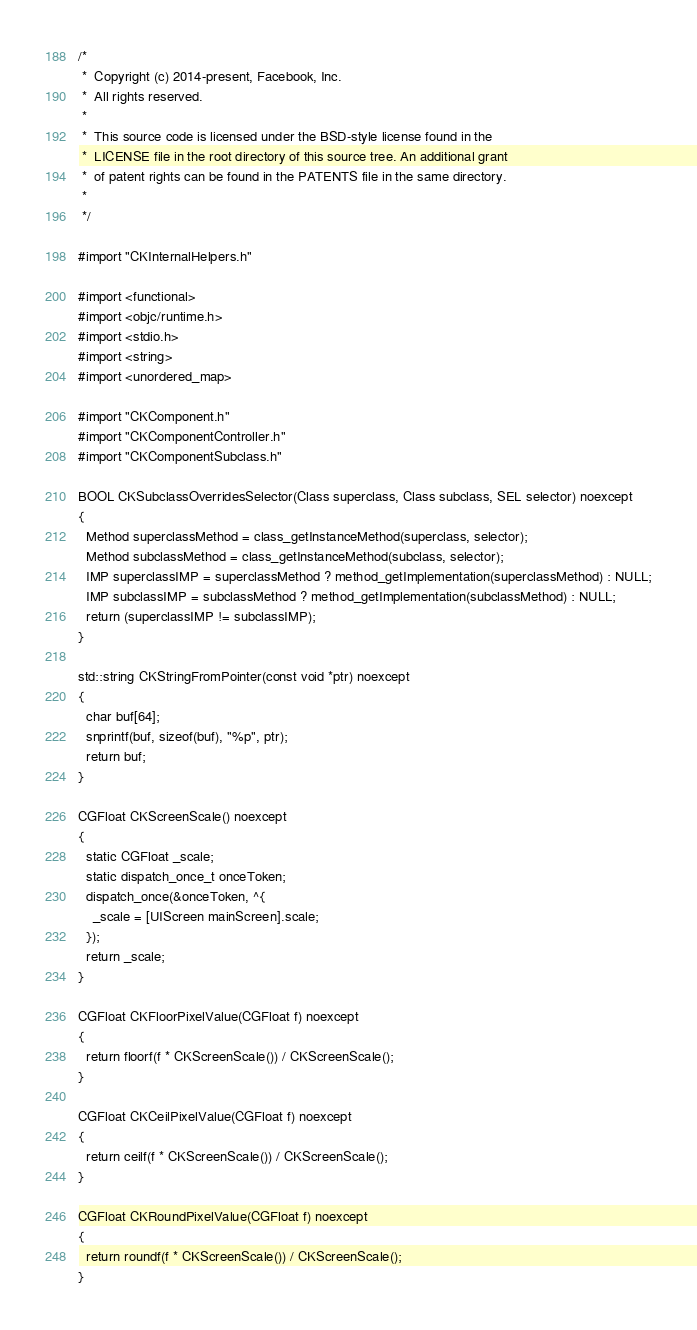Convert code to text. <code><loc_0><loc_0><loc_500><loc_500><_ObjectiveC_>/*
 *  Copyright (c) 2014-present, Facebook, Inc.
 *  All rights reserved.
 *
 *  This source code is licensed under the BSD-style license found in the
 *  LICENSE file in the root directory of this source tree. An additional grant
 *  of patent rights can be found in the PATENTS file in the same directory.
 *
 */

#import "CKInternalHelpers.h"

#import <functional>
#import <objc/runtime.h>
#import <stdio.h>
#import <string>
#import <unordered_map>

#import "CKComponent.h"
#import "CKComponentController.h"
#import "CKComponentSubclass.h"

BOOL CKSubclassOverridesSelector(Class superclass, Class subclass, SEL selector) noexcept
{
  Method superclassMethod = class_getInstanceMethod(superclass, selector);
  Method subclassMethod = class_getInstanceMethod(subclass, selector);
  IMP superclassIMP = superclassMethod ? method_getImplementation(superclassMethod) : NULL;
  IMP subclassIMP = subclassMethod ? method_getImplementation(subclassMethod) : NULL;
  return (superclassIMP != subclassIMP);
}

std::string CKStringFromPointer(const void *ptr) noexcept
{
  char buf[64];
  snprintf(buf, sizeof(buf), "%p", ptr);
  return buf;
}

CGFloat CKScreenScale() noexcept
{
  static CGFloat _scale;
  static dispatch_once_t onceToken;
  dispatch_once(&onceToken, ^{
    _scale = [UIScreen mainScreen].scale;
  });
  return _scale;
}

CGFloat CKFloorPixelValue(CGFloat f) noexcept
{
  return floorf(f * CKScreenScale()) / CKScreenScale();
}

CGFloat CKCeilPixelValue(CGFloat f) noexcept
{
  return ceilf(f * CKScreenScale()) / CKScreenScale();
}

CGFloat CKRoundPixelValue(CGFloat f) noexcept
{
  return roundf(f * CKScreenScale()) / CKScreenScale();
}
</code> 